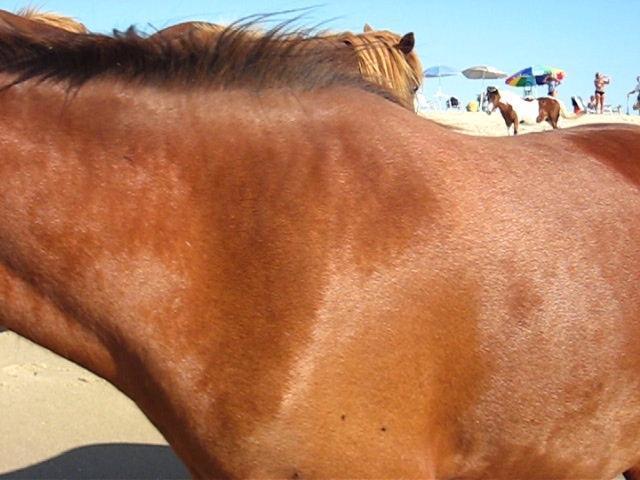What type flag elements appear in a pictured umbrella?
Make your selection from the four choices given to correctly answer the question.
Options: Nazi, american, gay rainbow, chilean. Gay rainbow. 